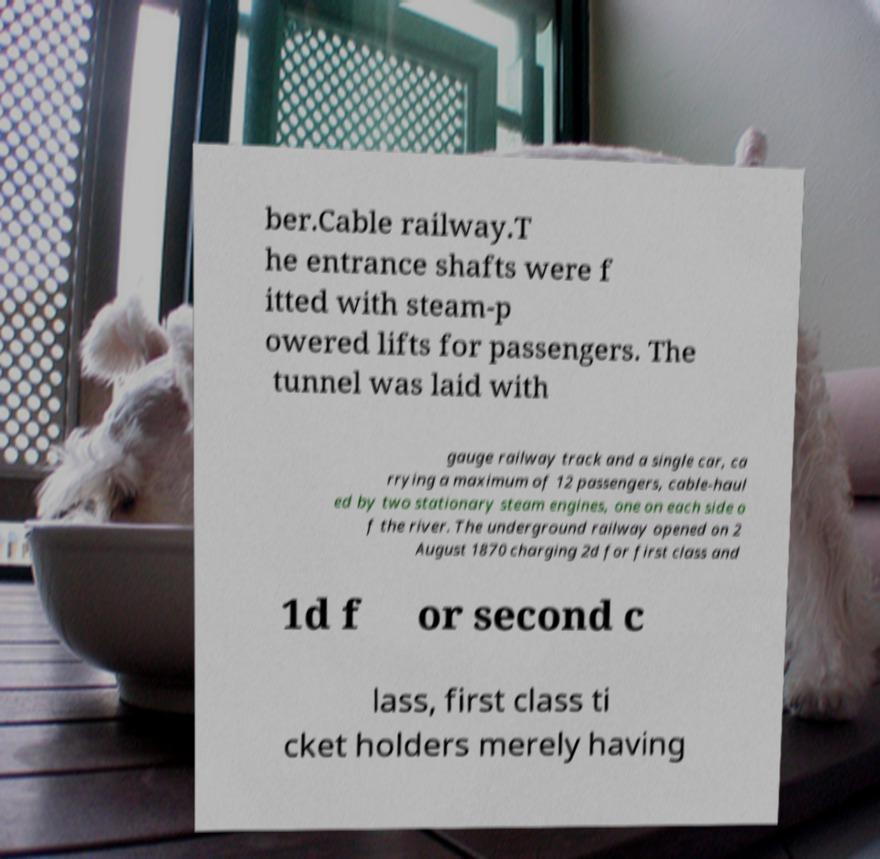Please identify and transcribe the text found in this image. ber.Cable railway.T he entrance shafts were f itted with steam-p owered lifts for passengers. The tunnel was laid with gauge railway track and a single car, ca rrying a maximum of 12 passengers, cable-haul ed by two stationary steam engines, one on each side o f the river. The underground railway opened on 2 August 1870 charging 2d for first class and 1d f or second c lass, first class ti cket holders merely having 